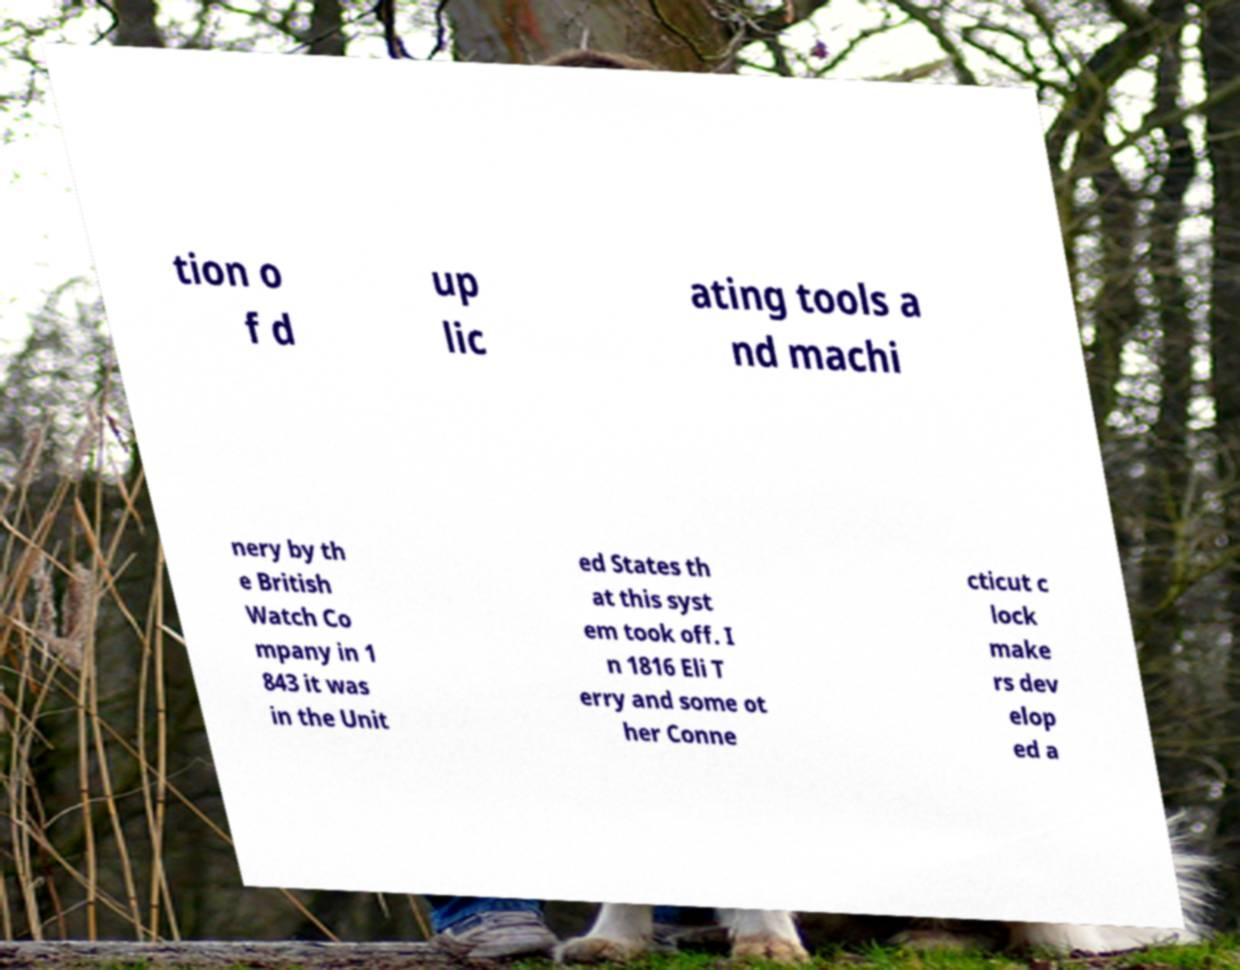I need the written content from this picture converted into text. Can you do that? tion o f d up lic ating tools a nd machi nery by th e British Watch Co mpany in 1 843 it was in the Unit ed States th at this syst em took off. I n 1816 Eli T erry and some ot her Conne cticut c lock make rs dev elop ed a 